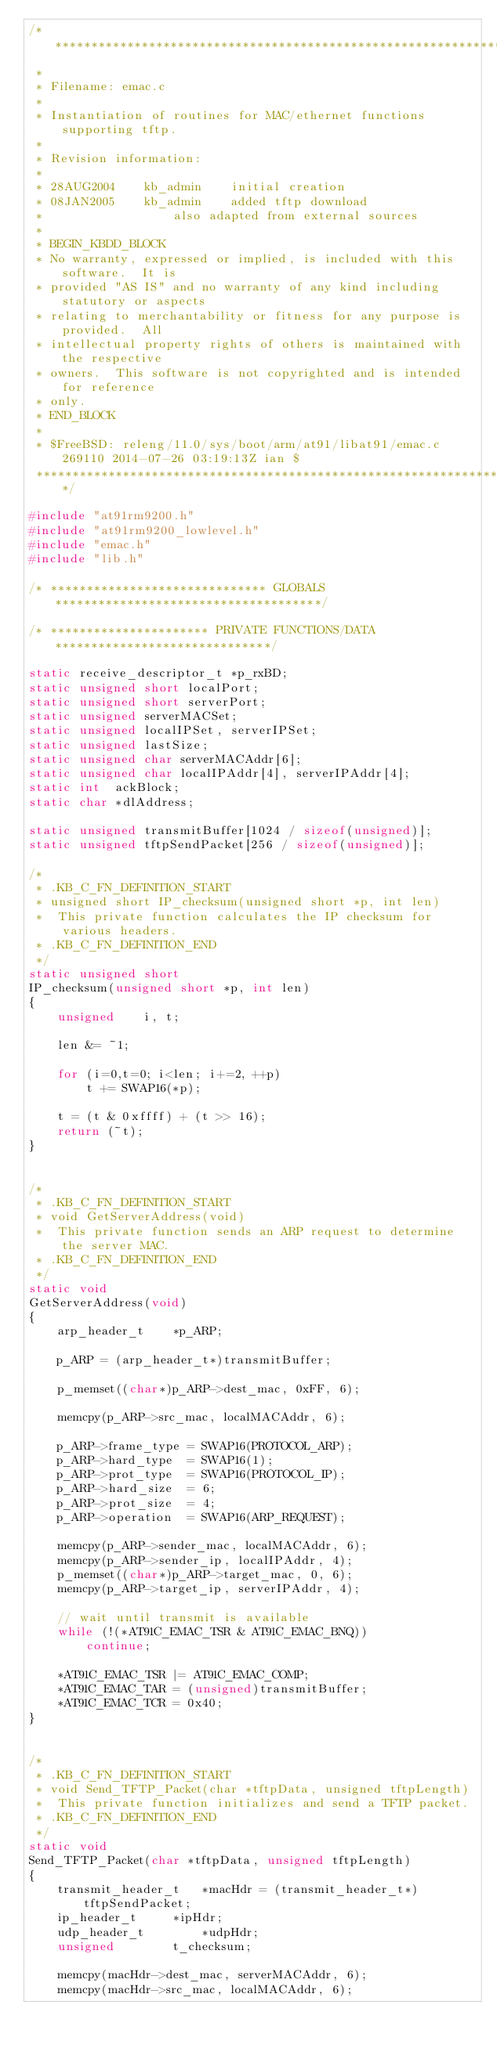<code> <loc_0><loc_0><loc_500><loc_500><_C_>/*******************************************************************************
 *
 * Filename: emac.c
 *
 * Instantiation of routines for MAC/ethernet functions supporting tftp.
 *
 * Revision information:
 *
 * 28AUG2004	kb_admin	initial creation
 * 08JAN2005	kb_admin	added tftp download
 *					also adapted from external sources
 *
 * BEGIN_KBDD_BLOCK
 * No warranty, expressed or implied, is included with this software.  It is
 * provided "AS IS" and no warranty of any kind including statutory or aspects
 * relating to merchantability or fitness for any purpose is provided.  All
 * intellectual property rights of others is maintained with the respective
 * owners.  This software is not copyrighted and is intended for reference
 * only.
 * END_BLOCK
 * 
 * $FreeBSD: releng/11.0/sys/boot/arm/at91/libat91/emac.c 269110 2014-07-26 03:19:13Z ian $
 ******************************************************************************/

#include "at91rm9200.h"
#include "at91rm9200_lowlevel.h"
#include "emac.h"
#include "lib.h"

/* ****************************** GLOBALS *************************************/

/* ********************** PRIVATE FUNCTIONS/DATA ******************************/

static receive_descriptor_t *p_rxBD;
static unsigned short localPort;
static unsigned short serverPort;
static unsigned serverMACSet;
static unsigned localIPSet, serverIPSet;
static unsigned	lastSize;
static unsigned char serverMACAddr[6];
static unsigned char localIPAddr[4], serverIPAddr[4];
static int	ackBlock;
static char *dlAddress;

static unsigned transmitBuffer[1024 / sizeof(unsigned)];
static unsigned tftpSendPacket[256 / sizeof(unsigned)];

/*
 * .KB_C_FN_DEFINITION_START
 * unsigned short IP_checksum(unsigned short *p, int len)
 *  This private function calculates the IP checksum for various headers.
 * .KB_C_FN_DEFINITION_END
 */
static unsigned short
IP_checksum(unsigned short *p, int len) 
{
	unsigned	i, t;

	len &= ~1;

	for (i=0,t=0; i<len; i+=2, ++p)
		t += SWAP16(*p);

	t = (t & 0xffff) + (t >> 16);
	return (~t);									
}


/*
 * .KB_C_FN_DEFINITION_START
 * void GetServerAddress(void)
 *  This private function sends an ARP request to determine the server MAC.
 * .KB_C_FN_DEFINITION_END
 */
static void
GetServerAddress(void)
{
	arp_header_t	*p_ARP;

	p_ARP = (arp_header_t*)transmitBuffer;

	p_memset((char*)p_ARP->dest_mac, 0xFF, 6);

	memcpy(p_ARP->src_mac, localMACAddr, 6);

	p_ARP->frame_type = SWAP16(PROTOCOL_ARP);
	p_ARP->hard_type  = SWAP16(1);
	p_ARP->prot_type  = SWAP16(PROTOCOL_IP);
	p_ARP->hard_size  = 6;
	p_ARP->prot_size  = 4;
	p_ARP->operation  = SWAP16(ARP_REQUEST);

	memcpy(p_ARP->sender_mac, localMACAddr, 6);
	memcpy(p_ARP->sender_ip, localIPAddr, 4);
	p_memset((char*)p_ARP->target_mac, 0, 6);
	memcpy(p_ARP->target_ip, serverIPAddr, 4);

	// wait until transmit is available
	while (!(*AT91C_EMAC_TSR & AT91C_EMAC_BNQ)) 
		continue;

  	*AT91C_EMAC_TSR |= AT91C_EMAC_COMP;
	*AT91C_EMAC_TAR = (unsigned)transmitBuffer;
	*AT91C_EMAC_TCR = 0x40;
}


/*
 * .KB_C_FN_DEFINITION_START
 * void Send_TFTP_Packet(char *tftpData, unsigned tftpLength)
 *  This private function initializes and send a TFTP packet.
 * .KB_C_FN_DEFINITION_END
 */
static void
Send_TFTP_Packet(char *tftpData, unsigned tftpLength)
{
	transmit_header_t	*macHdr = (transmit_header_t*)tftpSendPacket;
	ip_header_t		*ipHdr;
	udp_header_t		*udpHdr;
	unsigned		t_checksum;

	memcpy(macHdr->dest_mac, serverMACAddr, 6);
	memcpy(macHdr->src_mac, localMACAddr, 6);</code> 